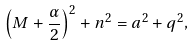Convert formula to latex. <formula><loc_0><loc_0><loc_500><loc_500>\left ( M + \frac { \alpha } { 2 } \right ) ^ { 2 } + n ^ { 2 } = a ^ { 2 } + q ^ { 2 } , \</formula> 